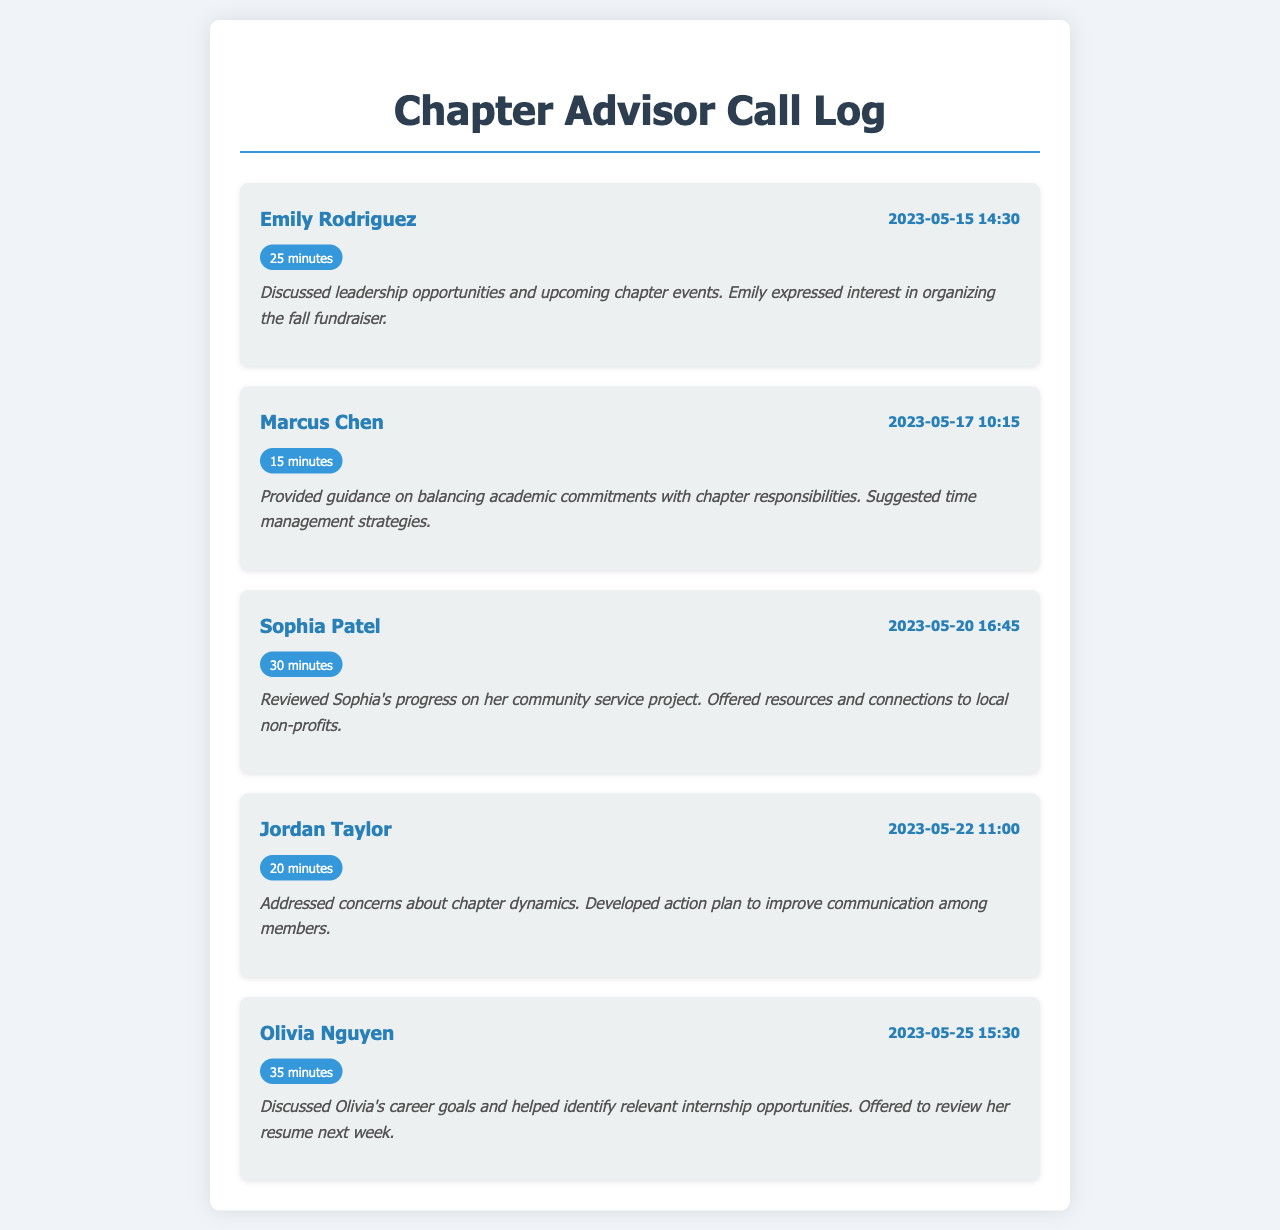What was the duration of Emily Rodriguez's call? The duration of Emily's call is listed in the call entry on May 15th, which is 25 minutes.
Answer: 25 minutes When did Marcus Chen have his mentoring session? The date and time of Marcus Chen's call can be found in the call entry on May 17th at 10:15.
Answer: 2023-05-17 10:15 What main topic did Jordan Taylor discuss during the call? The notes for Jordan's call summarize that he addressed concerns about chapter dynamics.
Answer: Chapter dynamics How long was Olivia Nguyen's call? The call entry for Olivia Nguyen notes the duration of her call as 35 minutes.
Answer: 35 minutes Who expressed interest in organizing a fall fundraiser? The notes from Emily Rodriguez's call indicate that she expressed interest in organizing the fall fundraiser.
Answer: Emily Rodriguez What was the purpose of the call with Sophia Patel? The call notes for Sophia Patel state that they reviewed her progress on her community service project.
Answer: Community service project How many minutes did Marcus Chen's call last? The call duration for Marcus Chen is specifically mentioned as 15 minutes in his entry.
Answer: 15 minutes What date was the call with Jordan Taylor? The date of Jordan Taylor's call is mentioned as May 22, as shown in the call entry.
Answer: 2023-05-22 What kind of opportunities did Olivia and the advisor discuss? The notes for Olivia Nguyan's call describe that they discussed relevant internship opportunities.
Answer: Internship opportunities 